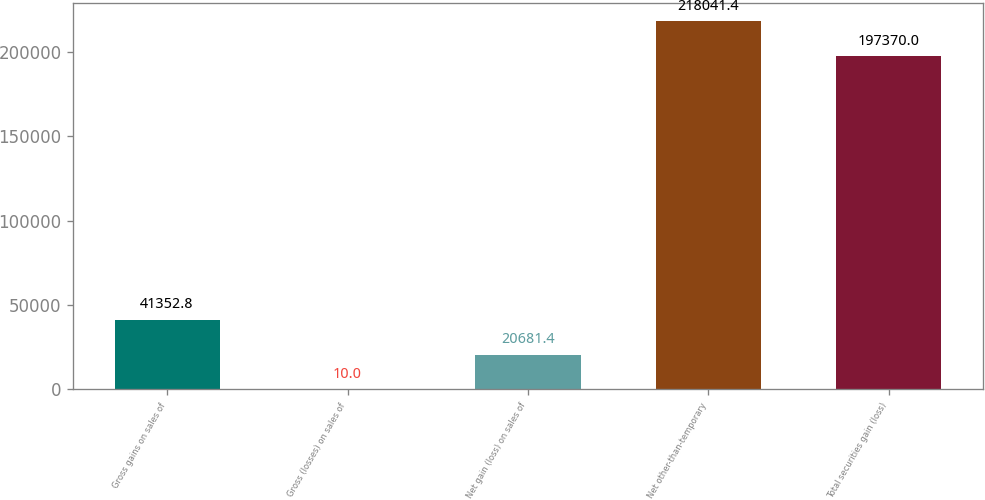Convert chart. <chart><loc_0><loc_0><loc_500><loc_500><bar_chart><fcel>Gross gains on sales of<fcel>Gross (losses) on sales of<fcel>Net gain (loss) on sales of<fcel>Net other-than-temporary<fcel>Total securities gain (loss)<nl><fcel>41352.8<fcel>10<fcel>20681.4<fcel>218041<fcel>197370<nl></chart> 